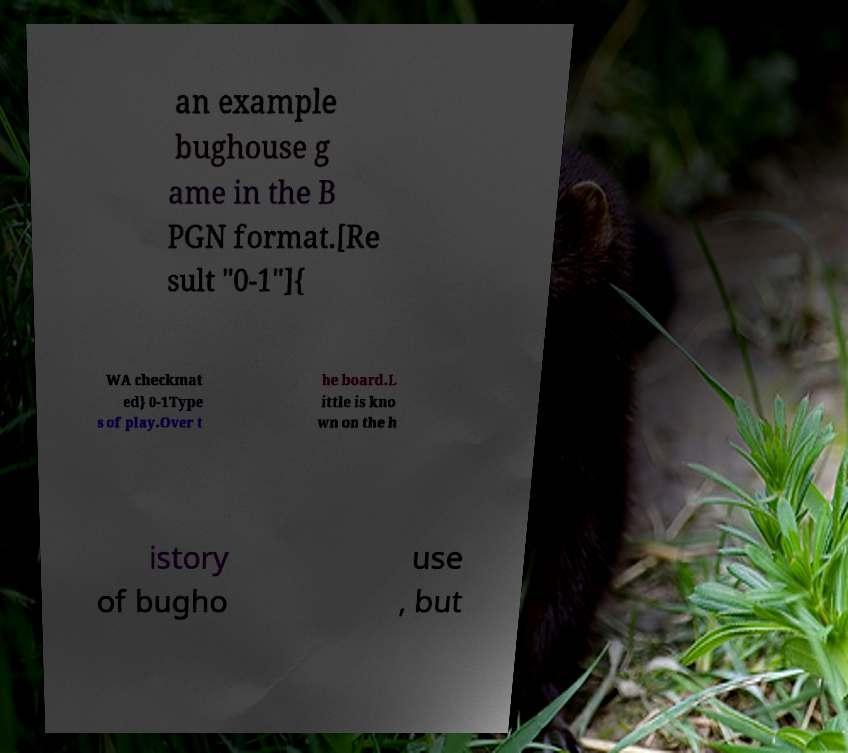Please read and relay the text visible in this image. What does it say? an example bughouse g ame in the B PGN format.[Re sult "0-1"]{ WA checkmat ed} 0-1Type s of play.Over t he board.L ittle is kno wn on the h istory of bugho use , but 